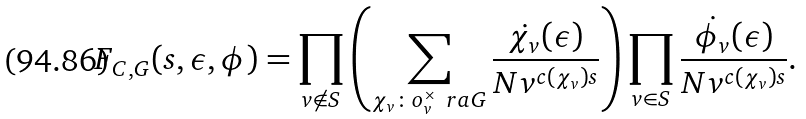<formula> <loc_0><loc_0><loc_500><loc_500>F _ { C , G } ( s , \epsilon , \phi ) = \prod _ { v \not \in S } \left ( \sum _ { \chi _ { v } \colon o _ { v } ^ { \times } \ r a G } \frac { \dot { \chi _ { v } } ( \epsilon ) } { N v ^ { c ( \chi _ { v } ) s } } \right ) \prod _ { v \in S } \frac { \dot { \phi _ { v } } ( \epsilon ) } { N v ^ { c ( \chi _ { v } ) s } } .</formula> 